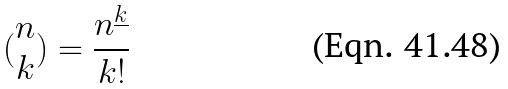<formula> <loc_0><loc_0><loc_500><loc_500>( \begin{matrix} n \\ k \end{matrix} ) = \frac { n ^ { \underline { k } } } { k ! }</formula> 